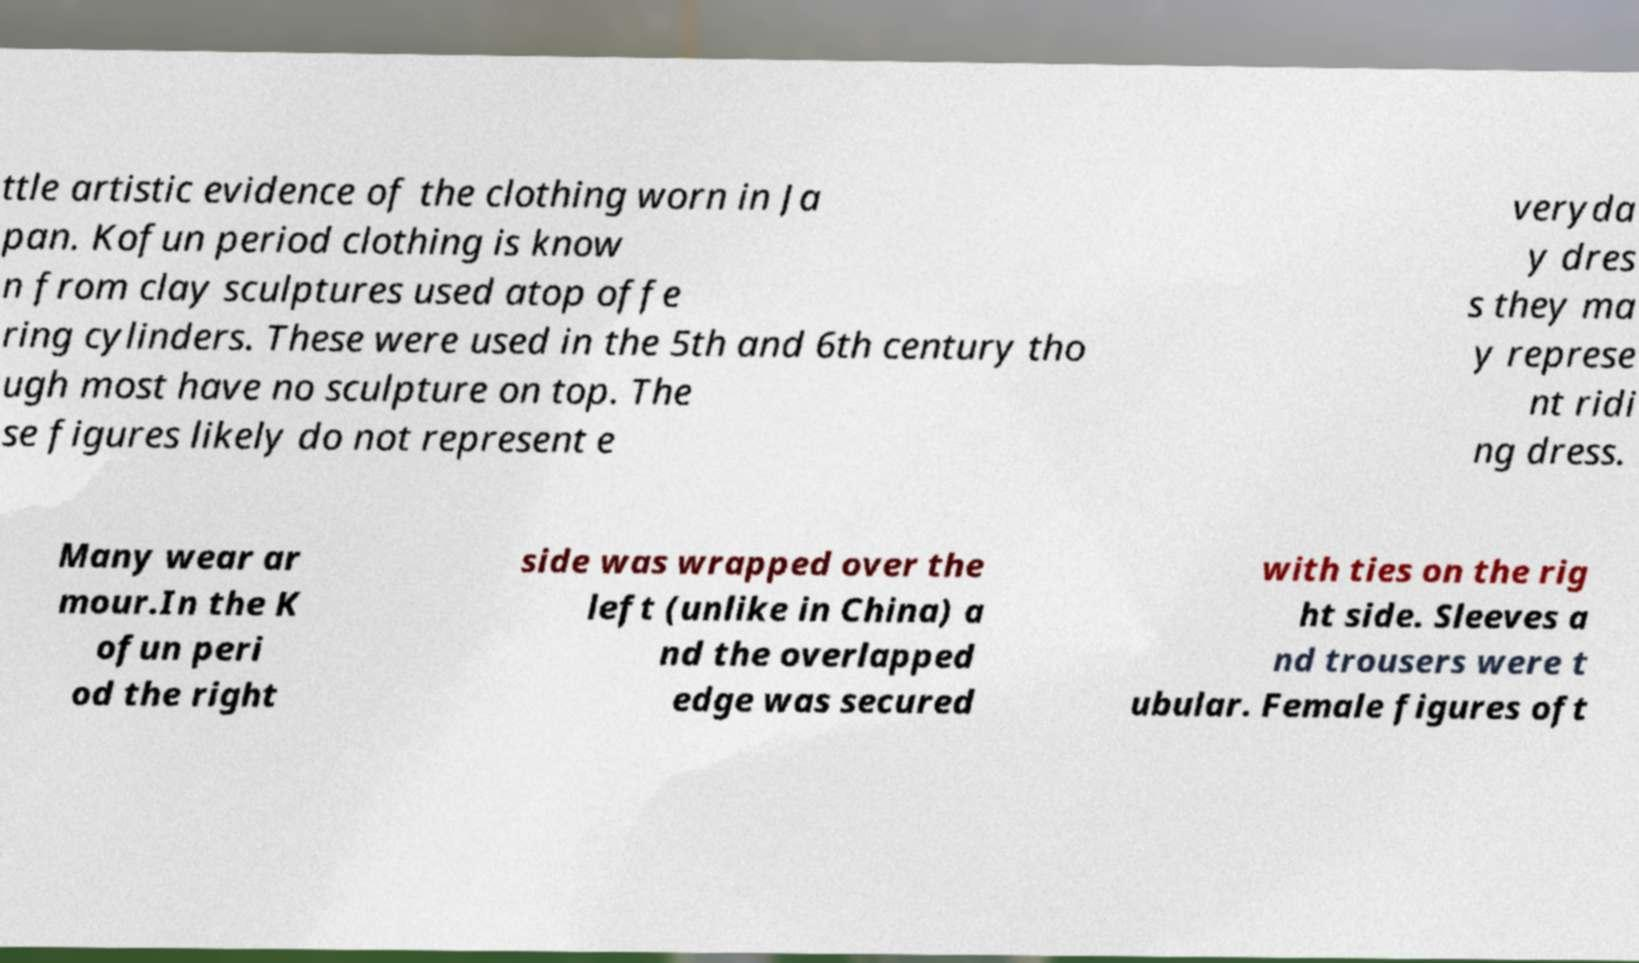What messages or text are displayed in this image? I need them in a readable, typed format. ttle artistic evidence of the clothing worn in Ja pan. Kofun period clothing is know n from clay sculptures used atop offe ring cylinders. These were used in the 5th and 6th century tho ugh most have no sculpture on top. The se figures likely do not represent e veryda y dres s they ma y represe nt ridi ng dress. Many wear ar mour.In the K ofun peri od the right side was wrapped over the left (unlike in China) a nd the overlapped edge was secured with ties on the rig ht side. Sleeves a nd trousers were t ubular. Female figures oft 